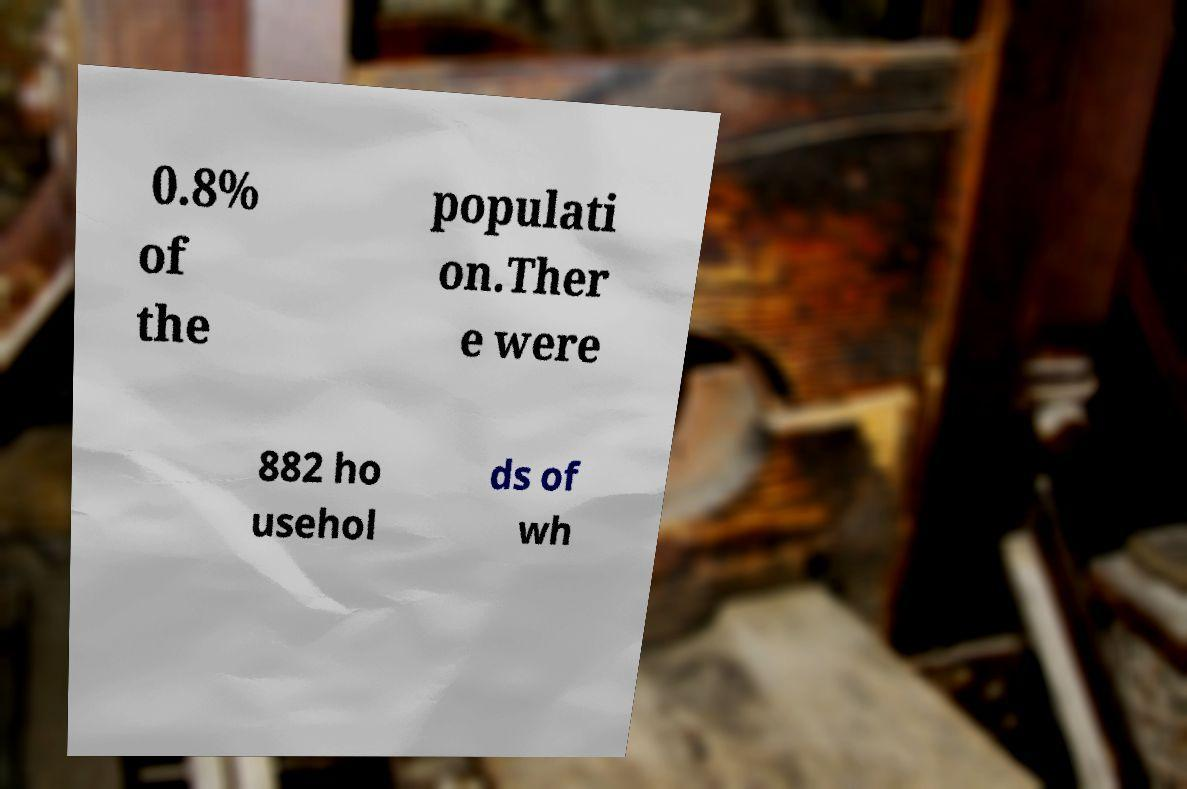Could you assist in decoding the text presented in this image and type it out clearly? 0.8% of the populati on.Ther e were 882 ho usehol ds of wh 